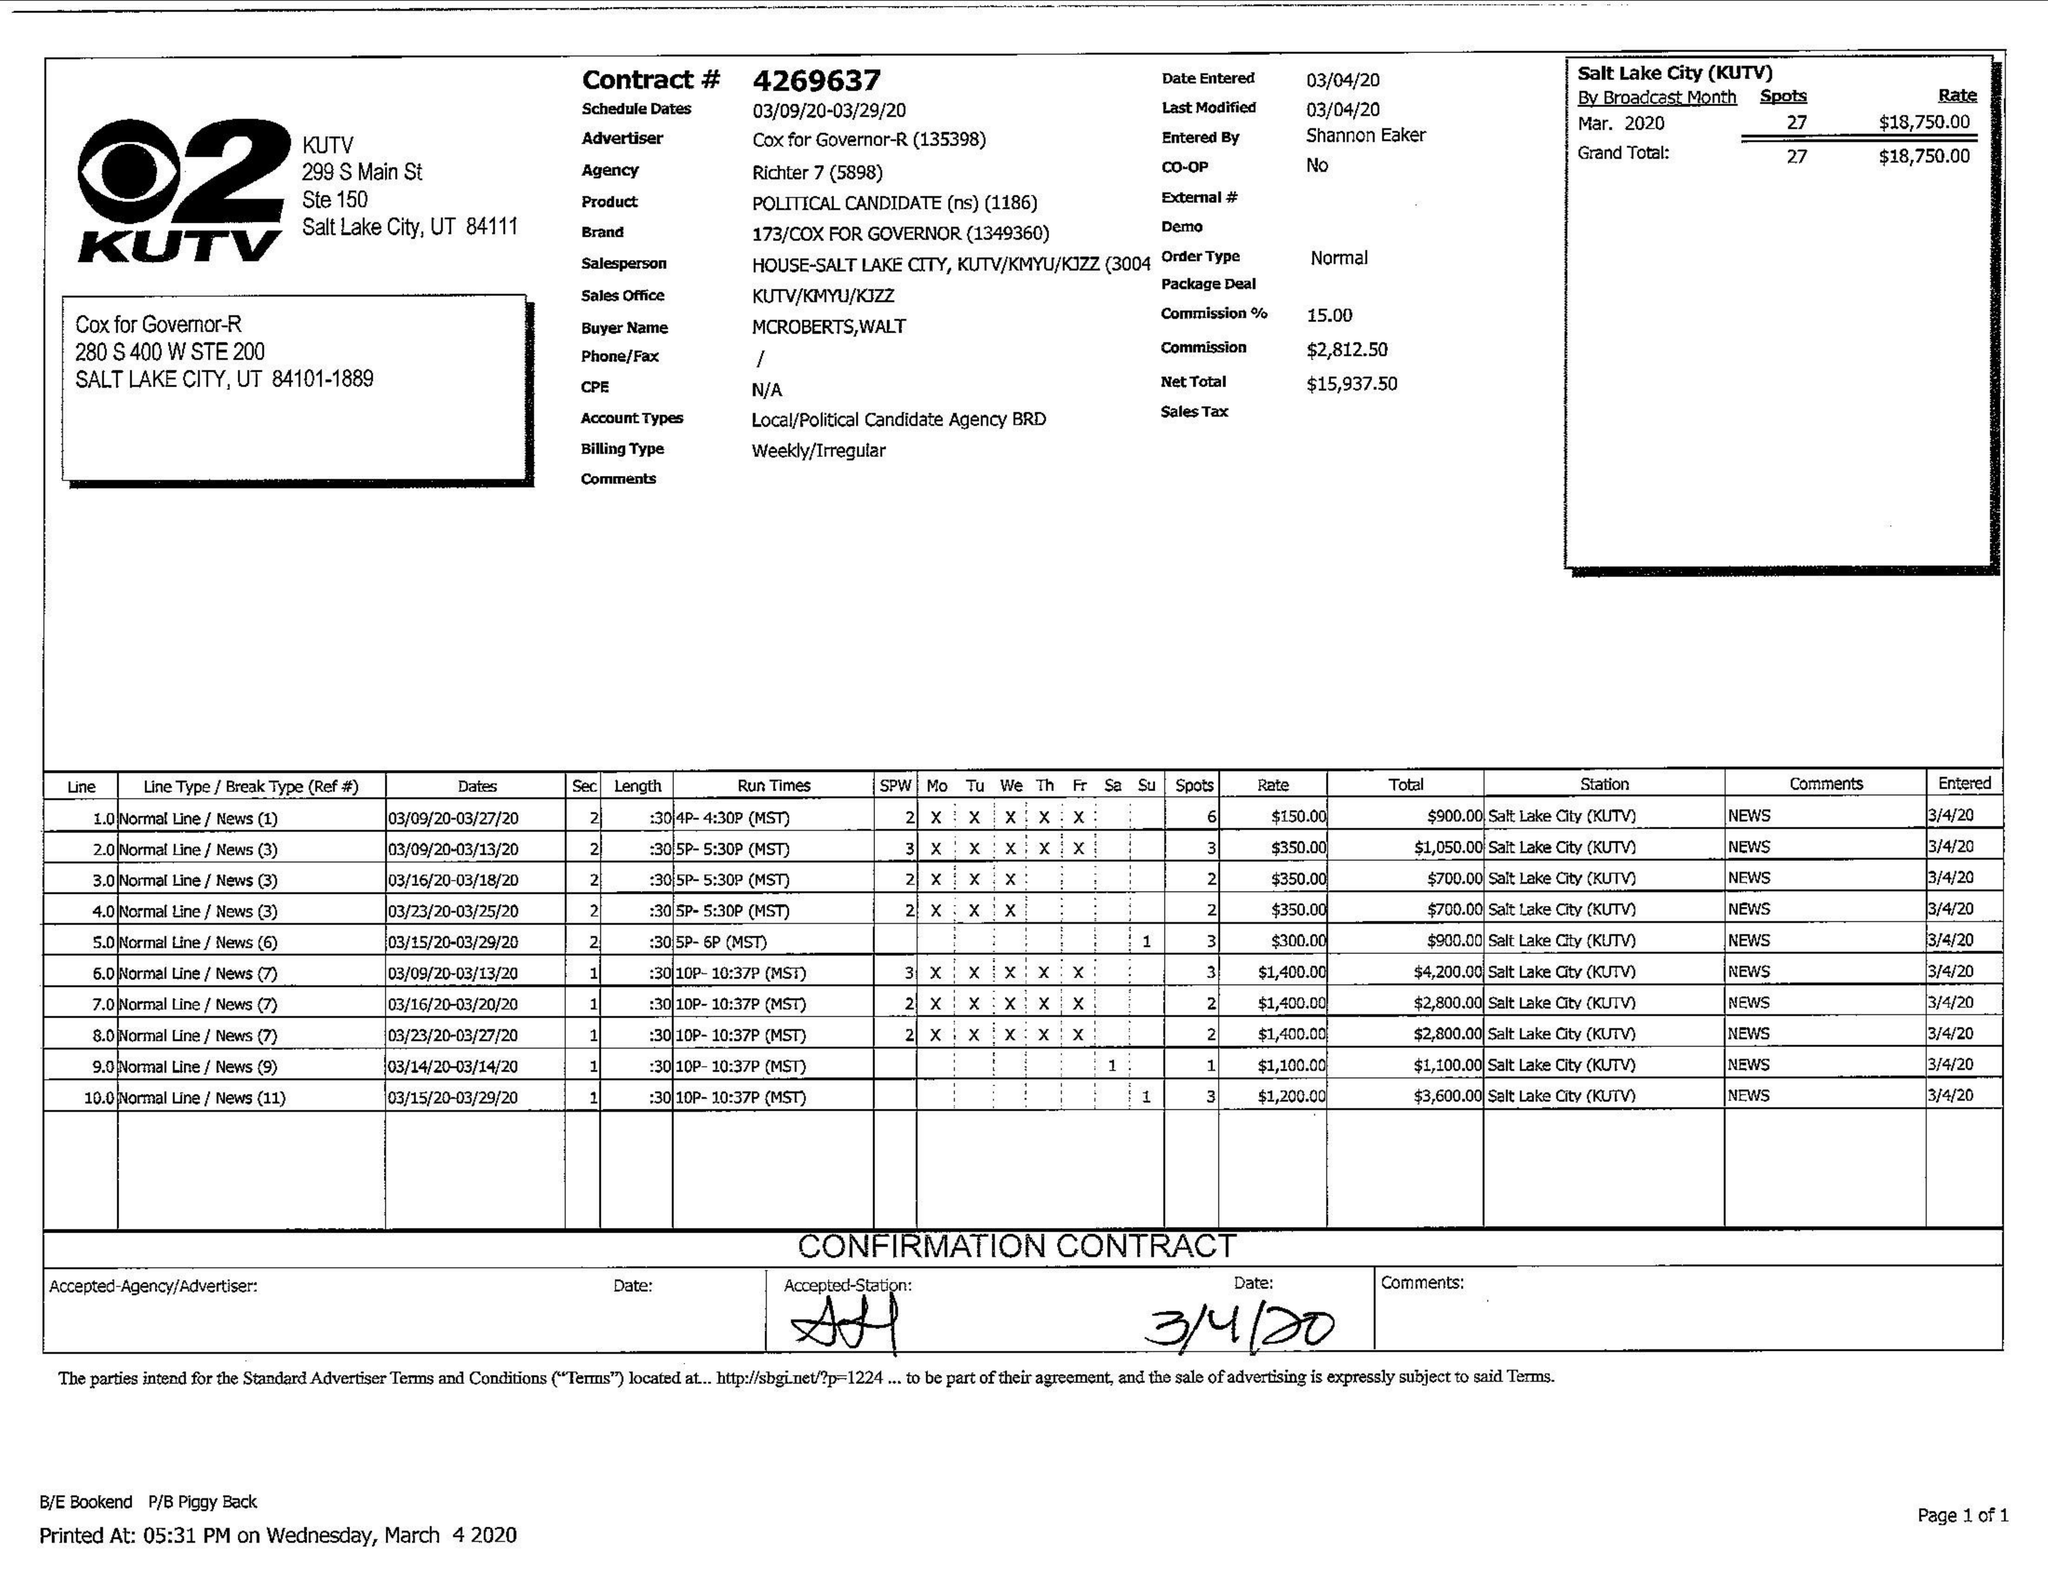What is the value for the gross_amount?
Answer the question using a single word or phrase. 18750.00 